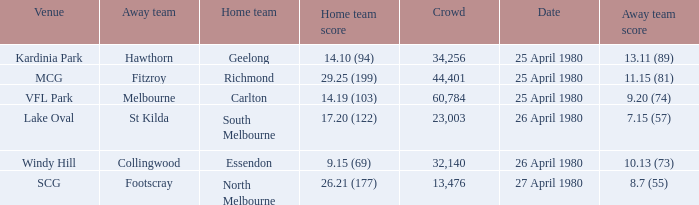What wa the date of the North Melbourne home game? 27 April 1980. 